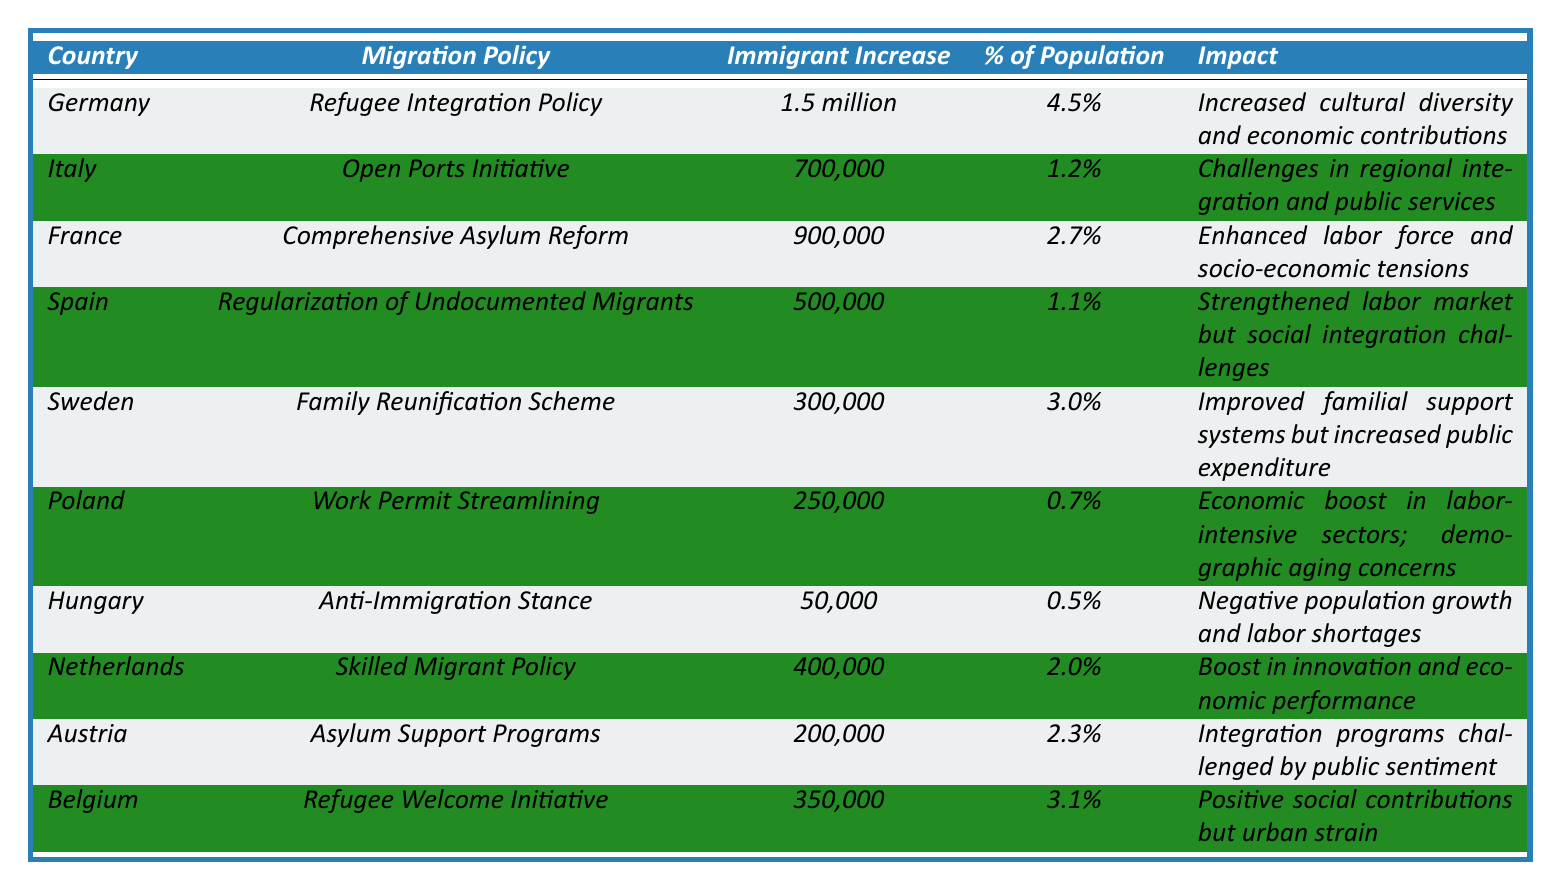What is the total immigrant population increase for EU countries listed? By summing the immigrant population increases for all listed countries: 1.5 million (Germany) + 700,000 (Italy) + 900,000 (France) + 500,000 (Spain) + 300,000 (Sweden) + 250,000 (Poland) + 50,000 (Hungary) + 400,000 (Netherlands) + 200,000 (Austria) + 350,000 (Belgium) = 5.5 million.
Answer: 5.5 million Which country had the highest percentage of population increase due to immigration? Comparing the percentages, Germany has the highest at 4.5%, followed by Belgium at 3.1%.
Answer: Germany Did Hungary experience positive population growth as a result of its migration policy? According to the data, Hungary had a negative population growth due to its anti-immigration stance, as reflected in the impact statement.
Answer: No What is the impact of Sweden's Family Reunification Scheme according to the table? The table indicates that Sweden's policy led to improved familial support systems but also resulted in increased public expenditure.
Answer: Improved familial support, increased public expenditure How many more immigrants did Italy receive compared to Poland? The difference in the immigrant population increase between Italy (700,000) and Poland (250,000) is 700,000 - 250,000 = 450,000.
Answer: 450,000 What is the overall impact mentioned for Italy's Open Ports Initiative? The overall impact for Italy's policy is described as challenges in regional integration and public services.
Answer: Challenges in regional integration and public services Which two countries saw the lowest increase in the immigrant population? From the data, the two countries with the lowest increases are Hungary (50,000) and Poland (250,000).
Answer: Hungary and Poland How does the impact of France’s Comprehensive Asylum Reform differ from that of Spain’s Regularization of Undocumented Migrants? France’s reform enhanced the labor force but introduced socio-economic tensions, whereas Spain's policy strengthened the labor market but presented social integration challenges, indicating different underlying issues.
Answer: Different underlying issues Calculate the average percentage of population increase due to immigration for the countries listed. To find the average, sum the percentages (4.5 + 1.2 + 2.7 + 1.1 + 3.0 + 0.7 + 0.5 + 2.0 + 2.3 + 3.1) = 19.1, then divide by the number of countries (10), yielding an average percentage of 19.1 / 10 = 1.91%.
Answer: 1.91% Did any country report an economic boost as a result of its migration policy? Yes, Poland reported an economic boost in labor-intensive sectors as a consequence of its Work Permit Streamlining policy.
Answer: Yes Which two countries reported challenges related to social integration? Spain and Italy both reported challenges related to social integration as part of their respective migration policies.
Answer: Spain and Italy 